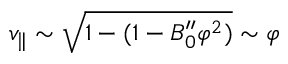Convert formula to latex. <formula><loc_0><loc_0><loc_500><loc_500>v _ { \| } \sim \sqrt { 1 - ( 1 - B _ { 0 } ^ { \prime \prime } \varphi ^ { 2 } ) } \sim \varphi</formula> 